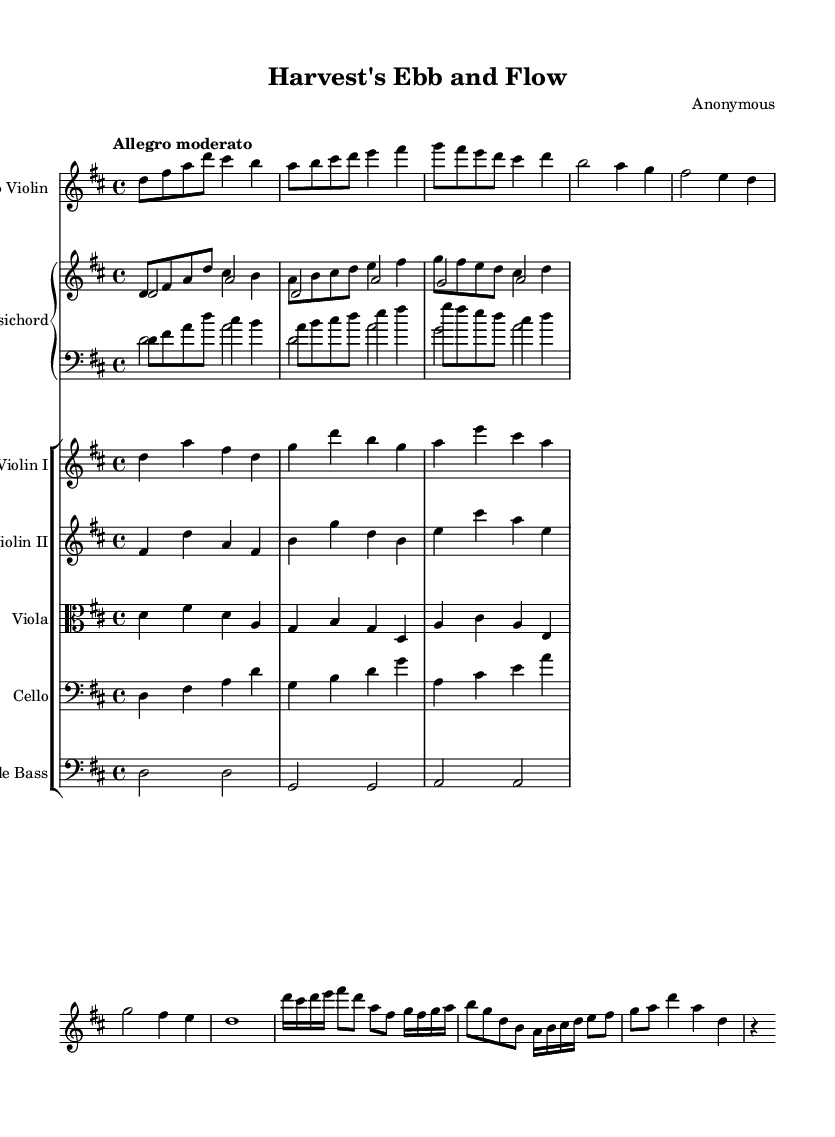What is the key signature of this music? The key signature is D major, which has two sharps (F# and C#). This can be identified by looking at the key signature indicator at the beginning of the music.
Answer: D major What is the time signature of this music? The time signature is 4/4, shown at the beginning of the piece. This means there are four beats in each measure, and the quarter note gets one beat.
Answer: 4/4 What is the tempo marking for this piece? The tempo marking is "Allegro moderato," which indicates a moderately fast pace. This is found in the tempo indication after the time signature.
Answer: Allegro moderato How many movements are in the piece? There are three distinct movements in this piece, as indicated by the changes in the flow and tempo throughout the score. Each section corresponds to a different seasonal theme.
Answer: 3 What seasonal theme corresponds to the first movement? The first movement corresponds to "Spring Planting," as indicated in the movement description within the score. This theme typically evokes the imagery of growth and new life.
Answer: Spring Planting Which instruments are featured as soloists in this concerto? The featured solo instrument in this concerto is the violin, while the other instruments provide a supporting role. This can be discerned from the title which emphasizes "Solo Violin."
Answer: Solo Violin What texture is prevalent in the opening section of this piece? The texture is primarily homophonic, with the solo violin playing a prominent melody supported by chordal accompaniments from the lower strings and harpsichord. This can be observed by the clear hierarchy of melody and harmony in the score.
Answer: Homophonic 